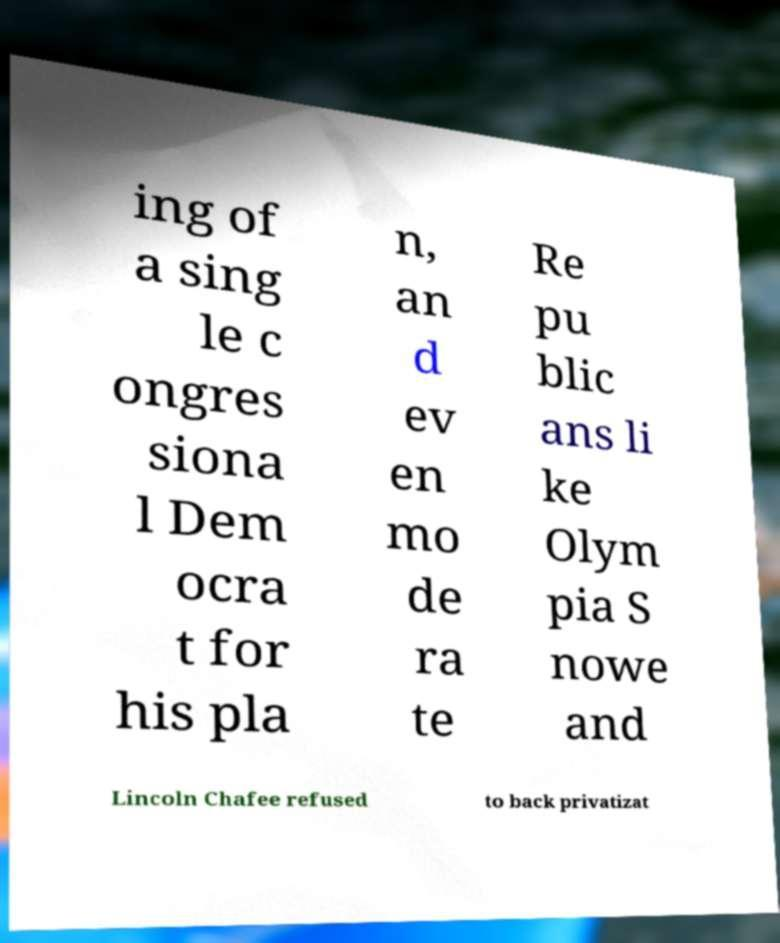Could you assist in decoding the text presented in this image and type it out clearly? ing of a sing le c ongres siona l Dem ocra t for his pla n, an d ev en mo de ra te Re pu blic ans li ke Olym pia S nowe and Lincoln Chafee refused to back privatizat 